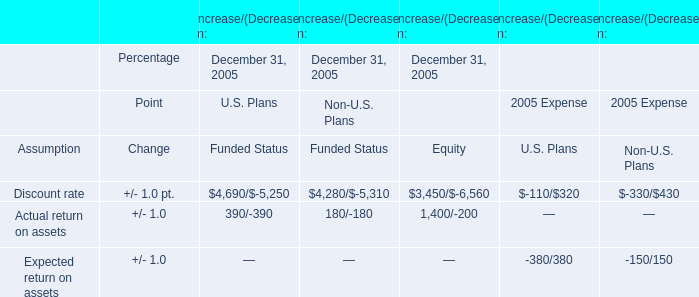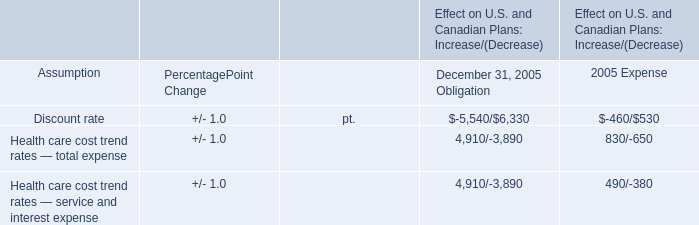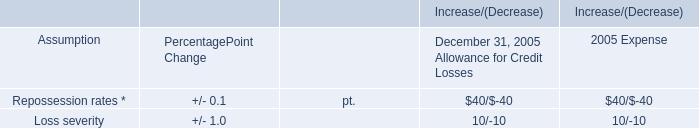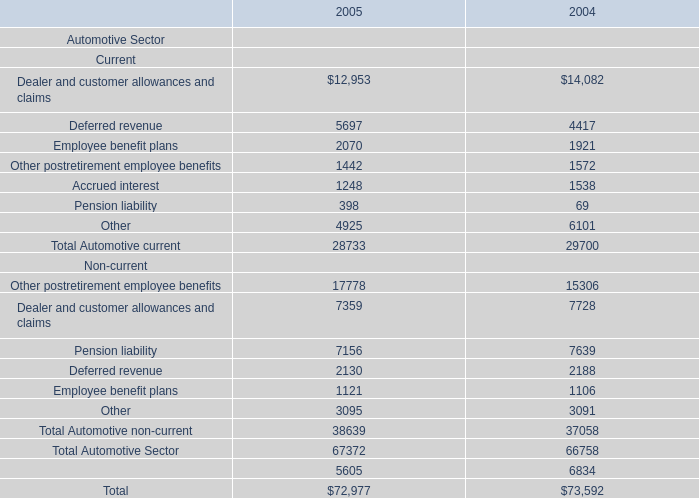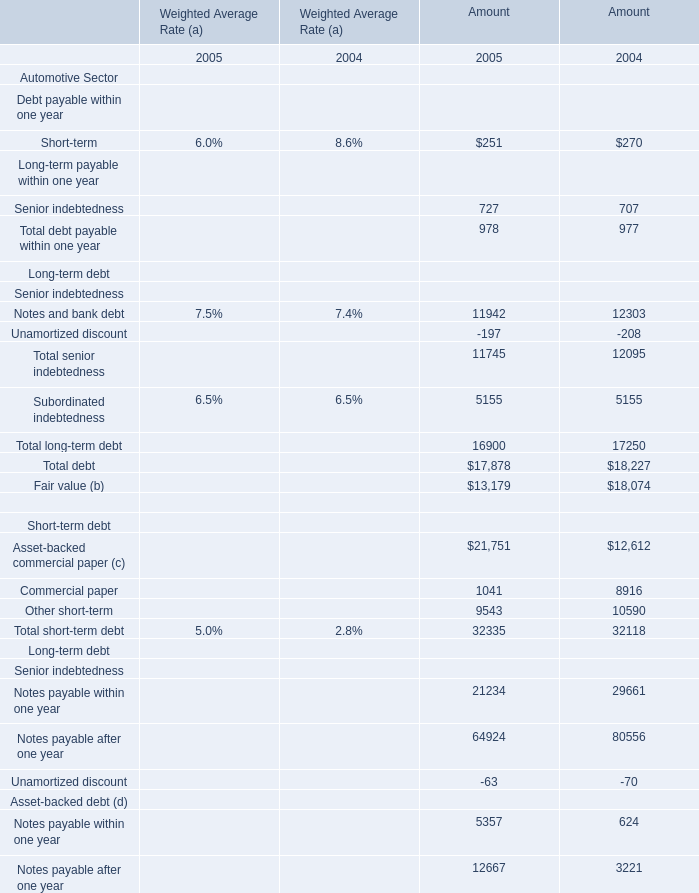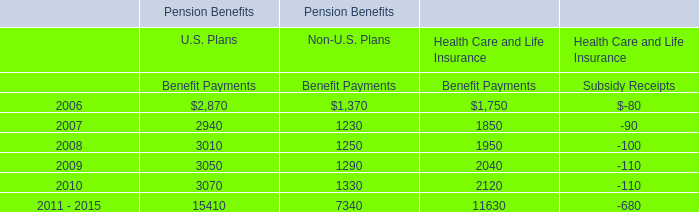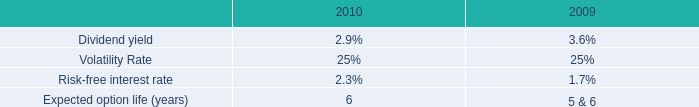What is the sum of the Total Automotive current in the years where Employee benefit plans is positive? 
Computations: (28733 + 29700)
Answer: 58433.0. 